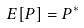Convert formula to latex. <formula><loc_0><loc_0><loc_500><loc_500>E [ P ] = P ^ { * }</formula> 